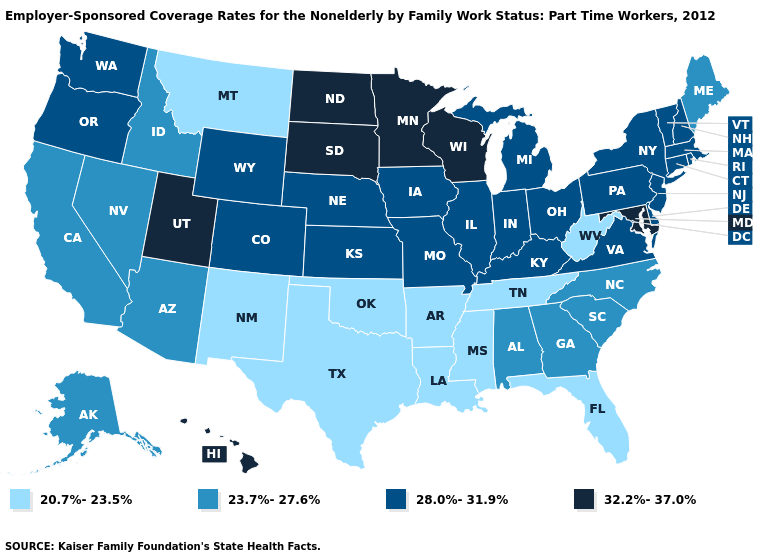Name the states that have a value in the range 20.7%-23.5%?
Be succinct. Arkansas, Florida, Louisiana, Mississippi, Montana, New Mexico, Oklahoma, Tennessee, Texas, West Virginia. Which states have the lowest value in the USA?
Write a very short answer. Arkansas, Florida, Louisiana, Mississippi, Montana, New Mexico, Oklahoma, Tennessee, Texas, West Virginia. What is the value of Florida?
Be succinct. 20.7%-23.5%. Name the states that have a value in the range 20.7%-23.5%?
Concise answer only. Arkansas, Florida, Louisiana, Mississippi, Montana, New Mexico, Oklahoma, Tennessee, Texas, West Virginia. Is the legend a continuous bar?
Quick response, please. No. Does Minnesota have a lower value than Iowa?
Give a very brief answer. No. What is the value of Kansas?
Give a very brief answer. 28.0%-31.9%. What is the value of Wyoming?
Write a very short answer. 28.0%-31.9%. What is the lowest value in states that border Colorado?
Give a very brief answer. 20.7%-23.5%. Name the states that have a value in the range 32.2%-37.0%?
Keep it brief. Hawaii, Maryland, Minnesota, North Dakota, South Dakota, Utah, Wisconsin. Does Tennessee have the lowest value in the USA?
Keep it brief. Yes. Does Nebraska have a lower value than Idaho?
Concise answer only. No. Does Florida have the lowest value in the USA?
Give a very brief answer. Yes. What is the lowest value in the USA?
Give a very brief answer. 20.7%-23.5%. What is the lowest value in states that border Wyoming?
Keep it brief. 20.7%-23.5%. 